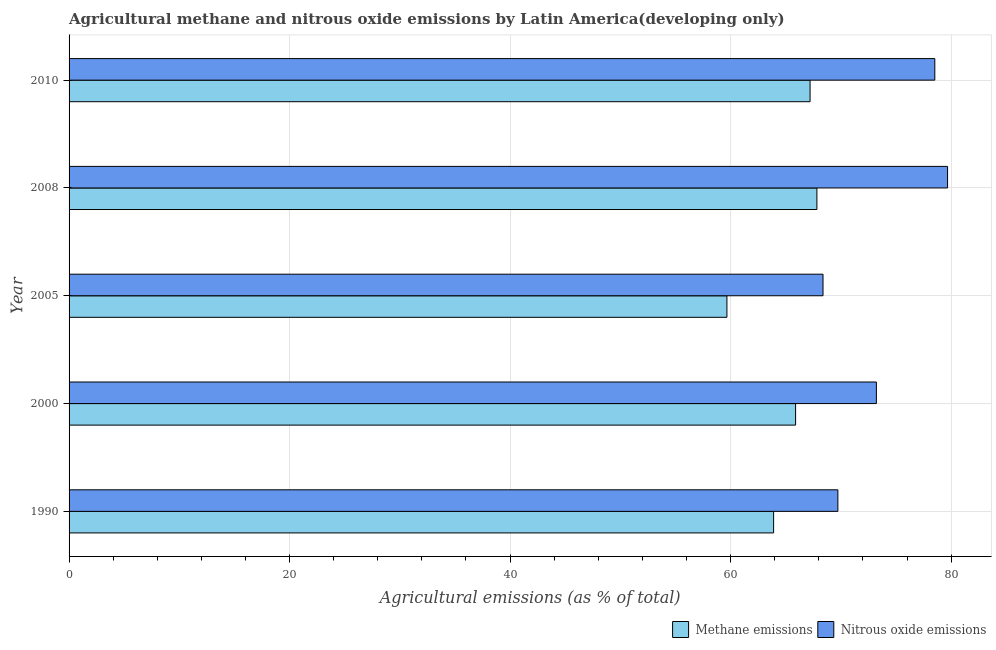How many groups of bars are there?
Offer a terse response. 5. Are the number of bars per tick equal to the number of legend labels?
Your response must be concise. Yes. How many bars are there on the 5th tick from the top?
Your answer should be compact. 2. What is the label of the 3rd group of bars from the top?
Provide a short and direct response. 2005. What is the amount of nitrous oxide emissions in 2000?
Make the answer very short. 73.22. Across all years, what is the maximum amount of methane emissions?
Your answer should be very brief. 67.83. Across all years, what is the minimum amount of nitrous oxide emissions?
Ensure brevity in your answer.  68.38. In which year was the amount of methane emissions maximum?
Ensure brevity in your answer.  2008. What is the total amount of methane emissions in the graph?
Ensure brevity in your answer.  324.5. What is the difference between the amount of nitrous oxide emissions in 2000 and that in 2010?
Keep it short and to the point. -5.3. What is the difference between the amount of nitrous oxide emissions in 2010 and the amount of methane emissions in 1990?
Your answer should be compact. 14.62. What is the average amount of nitrous oxide emissions per year?
Provide a succinct answer. 73.91. In the year 2010, what is the difference between the amount of methane emissions and amount of nitrous oxide emissions?
Your answer should be very brief. -11.31. In how many years, is the amount of nitrous oxide emissions greater than 72 %?
Offer a very short reply. 3. What is the ratio of the amount of nitrous oxide emissions in 1990 to that in 2008?
Provide a succinct answer. 0.88. Is the difference between the amount of methane emissions in 2005 and 2008 greater than the difference between the amount of nitrous oxide emissions in 2005 and 2008?
Provide a short and direct response. Yes. What is the difference between the highest and the second highest amount of nitrous oxide emissions?
Your response must be concise. 1.16. What is the difference between the highest and the lowest amount of methane emissions?
Make the answer very short. 8.16. In how many years, is the amount of nitrous oxide emissions greater than the average amount of nitrous oxide emissions taken over all years?
Offer a terse response. 2. What does the 1st bar from the top in 2010 represents?
Keep it short and to the point. Nitrous oxide emissions. What does the 1st bar from the bottom in 2000 represents?
Ensure brevity in your answer.  Methane emissions. Are all the bars in the graph horizontal?
Ensure brevity in your answer.  Yes. How many years are there in the graph?
Your answer should be compact. 5. What is the difference between two consecutive major ticks on the X-axis?
Keep it short and to the point. 20. Are the values on the major ticks of X-axis written in scientific E-notation?
Provide a short and direct response. No. Does the graph contain any zero values?
Offer a very short reply. No. Does the graph contain grids?
Your response must be concise. Yes. Where does the legend appear in the graph?
Make the answer very short. Bottom right. How many legend labels are there?
Provide a succinct answer. 2. What is the title of the graph?
Give a very brief answer. Agricultural methane and nitrous oxide emissions by Latin America(developing only). What is the label or title of the X-axis?
Make the answer very short. Agricultural emissions (as % of total). What is the label or title of the Y-axis?
Provide a short and direct response. Year. What is the Agricultural emissions (as % of total) of Methane emissions in 1990?
Your answer should be very brief. 63.9. What is the Agricultural emissions (as % of total) in Nitrous oxide emissions in 1990?
Keep it short and to the point. 69.73. What is the Agricultural emissions (as % of total) in Methane emissions in 2000?
Keep it short and to the point. 65.9. What is the Agricultural emissions (as % of total) in Nitrous oxide emissions in 2000?
Keep it short and to the point. 73.22. What is the Agricultural emissions (as % of total) of Methane emissions in 2005?
Offer a very short reply. 59.67. What is the Agricultural emissions (as % of total) of Nitrous oxide emissions in 2005?
Give a very brief answer. 68.38. What is the Agricultural emissions (as % of total) of Methane emissions in 2008?
Offer a very short reply. 67.83. What is the Agricultural emissions (as % of total) in Nitrous oxide emissions in 2008?
Make the answer very short. 79.68. What is the Agricultural emissions (as % of total) in Methane emissions in 2010?
Offer a very short reply. 67.21. What is the Agricultural emissions (as % of total) of Nitrous oxide emissions in 2010?
Keep it short and to the point. 78.52. Across all years, what is the maximum Agricultural emissions (as % of total) of Methane emissions?
Offer a terse response. 67.83. Across all years, what is the maximum Agricultural emissions (as % of total) of Nitrous oxide emissions?
Make the answer very short. 79.68. Across all years, what is the minimum Agricultural emissions (as % of total) in Methane emissions?
Keep it short and to the point. 59.67. Across all years, what is the minimum Agricultural emissions (as % of total) of Nitrous oxide emissions?
Give a very brief answer. 68.38. What is the total Agricultural emissions (as % of total) of Methane emissions in the graph?
Keep it short and to the point. 324.5. What is the total Agricultural emissions (as % of total) in Nitrous oxide emissions in the graph?
Offer a very short reply. 369.54. What is the difference between the Agricultural emissions (as % of total) of Methane emissions in 1990 and that in 2000?
Ensure brevity in your answer.  -1.99. What is the difference between the Agricultural emissions (as % of total) in Nitrous oxide emissions in 1990 and that in 2000?
Your answer should be very brief. -3.49. What is the difference between the Agricultural emissions (as % of total) of Methane emissions in 1990 and that in 2005?
Keep it short and to the point. 4.24. What is the difference between the Agricultural emissions (as % of total) in Nitrous oxide emissions in 1990 and that in 2005?
Your answer should be very brief. 1.35. What is the difference between the Agricultural emissions (as % of total) of Methane emissions in 1990 and that in 2008?
Offer a terse response. -3.93. What is the difference between the Agricultural emissions (as % of total) of Nitrous oxide emissions in 1990 and that in 2008?
Your answer should be compact. -9.95. What is the difference between the Agricultural emissions (as % of total) of Methane emissions in 1990 and that in 2010?
Make the answer very short. -3.31. What is the difference between the Agricultural emissions (as % of total) of Nitrous oxide emissions in 1990 and that in 2010?
Provide a short and direct response. -8.79. What is the difference between the Agricultural emissions (as % of total) in Methane emissions in 2000 and that in 2005?
Keep it short and to the point. 6.23. What is the difference between the Agricultural emissions (as % of total) of Nitrous oxide emissions in 2000 and that in 2005?
Give a very brief answer. 4.84. What is the difference between the Agricultural emissions (as % of total) in Methane emissions in 2000 and that in 2008?
Ensure brevity in your answer.  -1.93. What is the difference between the Agricultural emissions (as % of total) in Nitrous oxide emissions in 2000 and that in 2008?
Ensure brevity in your answer.  -6.46. What is the difference between the Agricultural emissions (as % of total) in Methane emissions in 2000 and that in 2010?
Offer a terse response. -1.31. What is the difference between the Agricultural emissions (as % of total) of Nitrous oxide emissions in 2000 and that in 2010?
Make the answer very short. -5.3. What is the difference between the Agricultural emissions (as % of total) of Methane emissions in 2005 and that in 2008?
Your response must be concise. -8.16. What is the difference between the Agricultural emissions (as % of total) in Nitrous oxide emissions in 2005 and that in 2008?
Keep it short and to the point. -11.3. What is the difference between the Agricultural emissions (as % of total) of Methane emissions in 2005 and that in 2010?
Offer a very short reply. -7.54. What is the difference between the Agricultural emissions (as % of total) of Nitrous oxide emissions in 2005 and that in 2010?
Ensure brevity in your answer.  -10.14. What is the difference between the Agricultural emissions (as % of total) of Methane emissions in 2008 and that in 2010?
Your answer should be compact. 0.62. What is the difference between the Agricultural emissions (as % of total) in Nitrous oxide emissions in 2008 and that in 2010?
Your answer should be very brief. 1.16. What is the difference between the Agricultural emissions (as % of total) in Methane emissions in 1990 and the Agricultural emissions (as % of total) in Nitrous oxide emissions in 2000?
Make the answer very short. -9.32. What is the difference between the Agricultural emissions (as % of total) in Methane emissions in 1990 and the Agricultural emissions (as % of total) in Nitrous oxide emissions in 2005?
Give a very brief answer. -4.48. What is the difference between the Agricultural emissions (as % of total) in Methane emissions in 1990 and the Agricultural emissions (as % of total) in Nitrous oxide emissions in 2008?
Give a very brief answer. -15.78. What is the difference between the Agricultural emissions (as % of total) in Methane emissions in 1990 and the Agricultural emissions (as % of total) in Nitrous oxide emissions in 2010?
Provide a succinct answer. -14.62. What is the difference between the Agricultural emissions (as % of total) of Methane emissions in 2000 and the Agricultural emissions (as % of total) of Nitrous oxide emissions in 2005?
Give a very brief answer. -2.49. What is the difference between the Agricultural emissions (as % of total) in Methane emissions in 2000 and the Agricultural emissions (as % of total) in Nitrous oxide emissions in 2008?
Offer a very short reply. -13.78. What is the difference between the Agricultural emissions (as % of total) of Methane emissions in 2000 and the Agricultural emissions (as % of total) of Nitrous oxide emissions in 2010?
Make the answer very short. -12.63. What is the difference between the Agricultural emissions (as % of total) of Methane emissions in 2005 and the Agricultural emissions (as % of total) of Nitrous oxide emissions in 2008?
Make the answer very short. -20.01. What is the difference between the Agricultural emissions (as % of total) in Methane emissions in 2005 and the Agricultural emissions (as % of total) in Nitrous oxide emissions in 2010?
Your response must be concise. -18.86. What is the difference between the Agricultural emissions (as % of total) of Methane emissions in 2008 and the Agricultural emissions (as % of total) of Nitrous oxide emissions in 2010?
Your answer should be compact. -10.69. What is the average Agricultural emissions (as % of total) in Methane emissions per year?
Provide a short and direct response. 64.9. What is the average Agricultural emissions (as % of total) of Nitrous oxide emissions per year?
Make the answer very short. 73.91. In the year 1990, what is the difference between the Agricultural emissions (as % of total) of Methane emissions and Agricultural emissions (as % of total) of Nitrous oxide emissions?
Give a very brief answer. -5.83. In the year 2000, what is the difference between the Agricultural emissions (as % of total) of Methane emissions and Agricultural emissions (as % of total) of Nitrous oxide emissions?
Provide a short and direct response. -7.33. In the year 2005, what is the difference between the Agricultural emissions (as % of total) of Methane emissions and Agricultural emissions (as % of total) of Nitrous oxide emissions?
Your answer should be compact. -8.72. In the year 2008, what is the difference between the Agricultural emissions (as % of total) of Methane emissions and Agricultural emissions (as % of total) of Nitrous oxide emissions?
Your answer should be compact. -11.85. In the year 2010, what is the difference between the Agricultural emissions (as % of total) in Methane emissions and Agricultural emissions (as % of total) in Nitrous oxide emissions?
Offer a terse response. -11.31. What is the ratio of the Agricultural emissions (as % of total) in Methane emissions in 1990 to that in 2000?
Ensure brevity in your answer.  0.97. What is the ratio of the Agricultural emissions (as % of total) in Nitrous oxide emissions in 1990 to that in 2000?
Offer a very short reply. 0.95. What is the ratio of the Agricultural emissions (as % of total) in Methane emissions in 1990 to that in 2005?
Provide a short and direct response. 1.07. What is the ratio of the Agricultural emissions (as % of total) in Nitrous oxide emissions in 1990 to that in 2005?
Offer a terse response. 1.02. What is the ratio of the Agricultural emissions (as % of total) of Methane emissions in 1990 to that in 2008?
Provide a short and direct response. 0.94. What is the ratio of the Agricultural emissions (as % of total) in Nitrous oxide emissions in 1990 to that in 2008?
Provide a short and direct response. 0.88. What is the ratio of the Agricultural emissions (as % of total) of Methane emissions in 1990 to that in 2010?
Your response must be concise. 0.95. What is the ratio of the Agricultural emissions (as % of total) in Nitrous oxide emissions in 1990 to that in 2010?
Ensure brevity in your answer.  0.89. What is the ratio of the Agricultural emissions (as % of total) in Methane emissions in 2000 to that in 2005?
Ensure brevity in your answer.  1.1. What is the ratio of the Agricultural emissions (as % of total) of Nitrous oxide emissions in 2000 to that in 2005?
Your answer should be very brief. 1.07. What is the ratio of the Agricultural emissions (as % of total) in Methane emissions in 2000 to that in 2008?
Your answer should be compact. 0.97. What is the ratio of the Agricultural emissions (as % of total) of Nitrous oxide emissions in 2000 to that in 2008?
Ensure brevity in your answer.  0.92. What is the ratio of the Agricultural emissions (as % of total) of Methane emissions in 2000 to that in 2010?
Your response must be concise. 0.98. What is the ratio of the Agricultural emissions (as % of total) in Nitrous oxide emissions in 2000 to that in 2010?
Provide a succinct answer. 0.93. What is the ratio of the Agricultural emissions (as % of total) in Methane emissions in 2005 to that in 2008?
Your response must be concise. 0.88. What is the ratio of the Agricultural emissions (as % of total) in Nitrous oxide emissions in 2005 to that in 2008?
Keep it short and to the point. 0.86. What is the ratio of the Agricultural emissions (as % of total) of Methane emissions in 2005 to that in 2010?
Offer a terse response. 0.89. What is the ratio of the Agricultural emissions (as % of total) of Nitrous oxide emissions in 2005 to that in 2010?
Your answer should be compact. 0.87. What is the ratio of the Agricultural emissions (as % of total) of Methane emissions in 2008 to that in 2010?
Ensure brevity in your answer.  1.01. What is the ratio of the Agricultural emissions (as % of total) of Nitrous oxide emissions in 2008 to that in 2010?
Provide a short and direct response. 1.01. What is the difference between the highest and the second highest Agricultural emissions (as % of total) of Methane emissions?
Offer a terse response. 0.62. What is the difference between the highest and the second highest Agricultural emissions (as % of total) of Nitrous oxide emissions?
Your answer should be compact. 1.16. What is the difference between the highest and the lowest Agricultural emissions (as % of total) of Methane emissions?
Offer a terse response. 8.16. What is the difference between the highest and the lowest Agricultural emissions (as % of total) of Nitrous oxide emissions?
Ensure brevity in your answer.  11.3. 